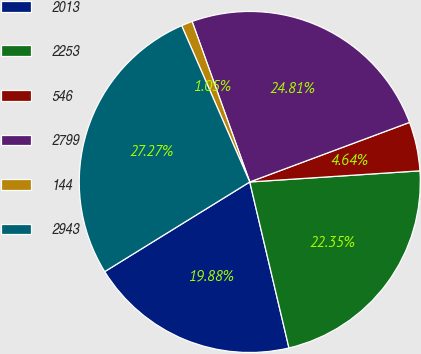Convert chart. <chart><loc_0><loc_0><loc_500><loc_500><pie_chart><fcel>2013<fcel>2253<fcel>546<fcel>2799<fcel>144<fcel>2943<nl><fcel>19.88%<fcel>22.35%<fcel>4.64%<fcel>24.81%<fcel>1.05%<fcel>27.27%<nl></chart> 